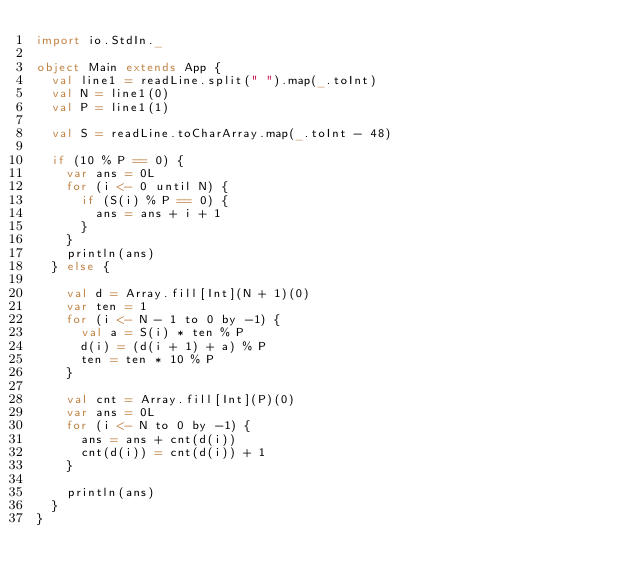Convert code to text. <code><loc_0><loc_0><loc_500><loc_500><_Scala_>import io.StdIn._

object Main extends App {
  val line1 = readLine.split(" ").map(_.toInt)
  val N = line1(0)
  val P = line1(1)

  val S = readLine.toCharArray.map(_.toInt - 48)

  if (10 % P == 0) {
    var ans = 0L
    for (i <- 0 until N) {
      if (S(i) % P == 0) {
        ans = ans + i + 1
      }
    }
    println(ans)
  } else {

    val d = Array.fill[Int](N + 1)(0)
    var ten = 1
    for (i <- N - 1 to 0 by -1) {
      val a = S(i) * ten % P
      d(i) = (d(i + 1) + a) % P
      ten = ten * 10 % P
    }

    val cnt = Array.fill[Int](P)(0)
    var ans = 0L
    for (i <- N to 0 by -1) {
      ans = ans + cnt(d(i))
      cnt(d(i)) = cnt(d(i)) + 1
    }

    println(ans)
  }
}
</code> 